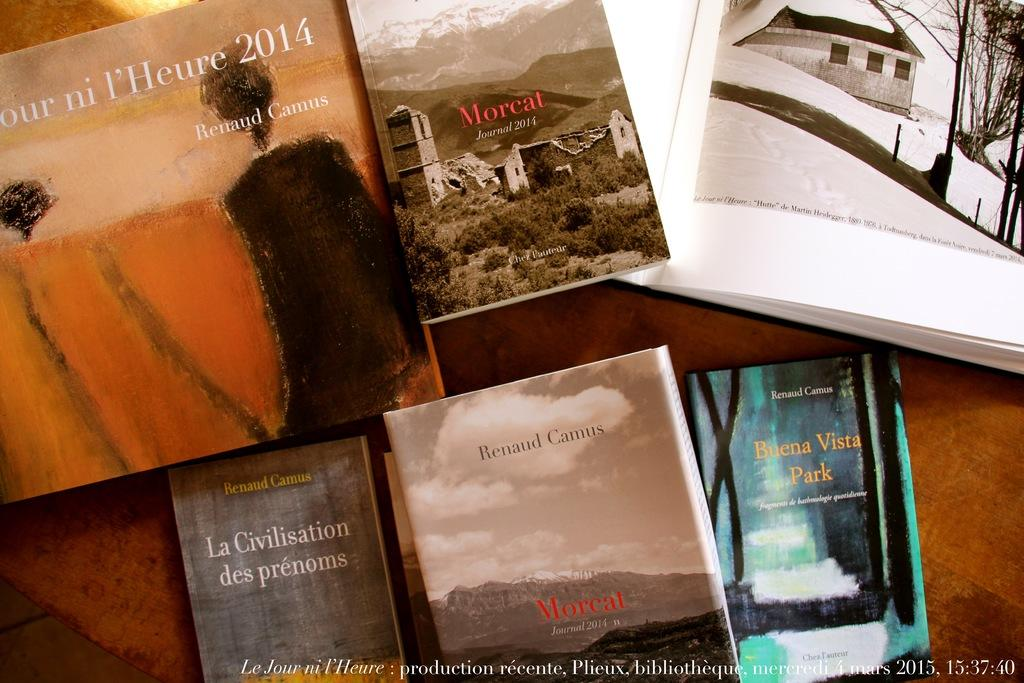<image>
Share a concise interpretation of the image provided. Books placed on a table with a book by Renaud Camus near the bottom. 